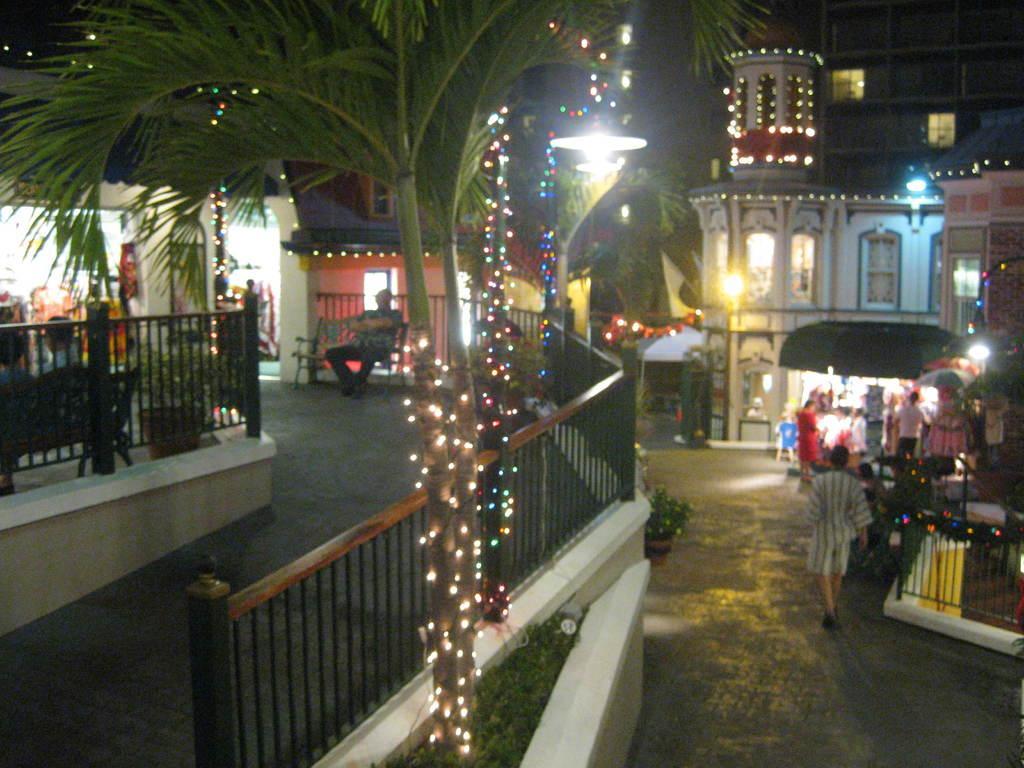How would you summarize this image in a sentence or two? In this image in the front there are plants and there is grass. On the right side there are persons, there are tents and there are light poles, there are buildings. On the left side there are persons sitting and there is a black colour fence and there is a building. 